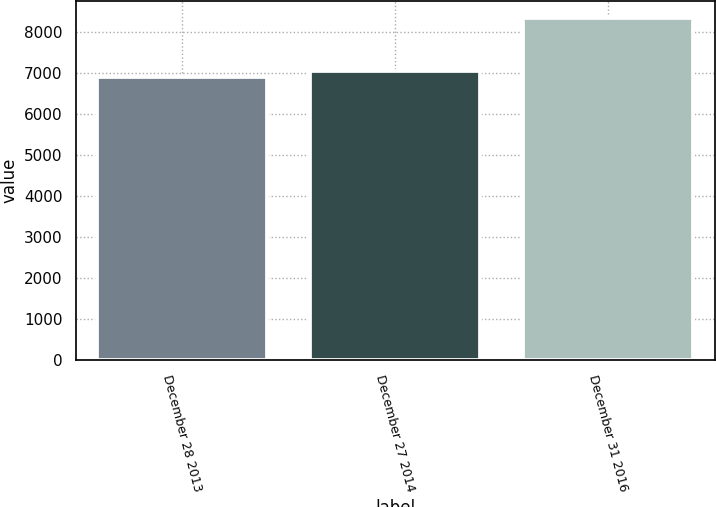<chart> <loc_0><loc_0><loc_500><loc_500><bar_chart><fcel>December 28 2013<fcel>December 27 2014<fcel>December 31 2016<nl><fcel>6894<fcel>7038<fcel>8334<nl></chart> 